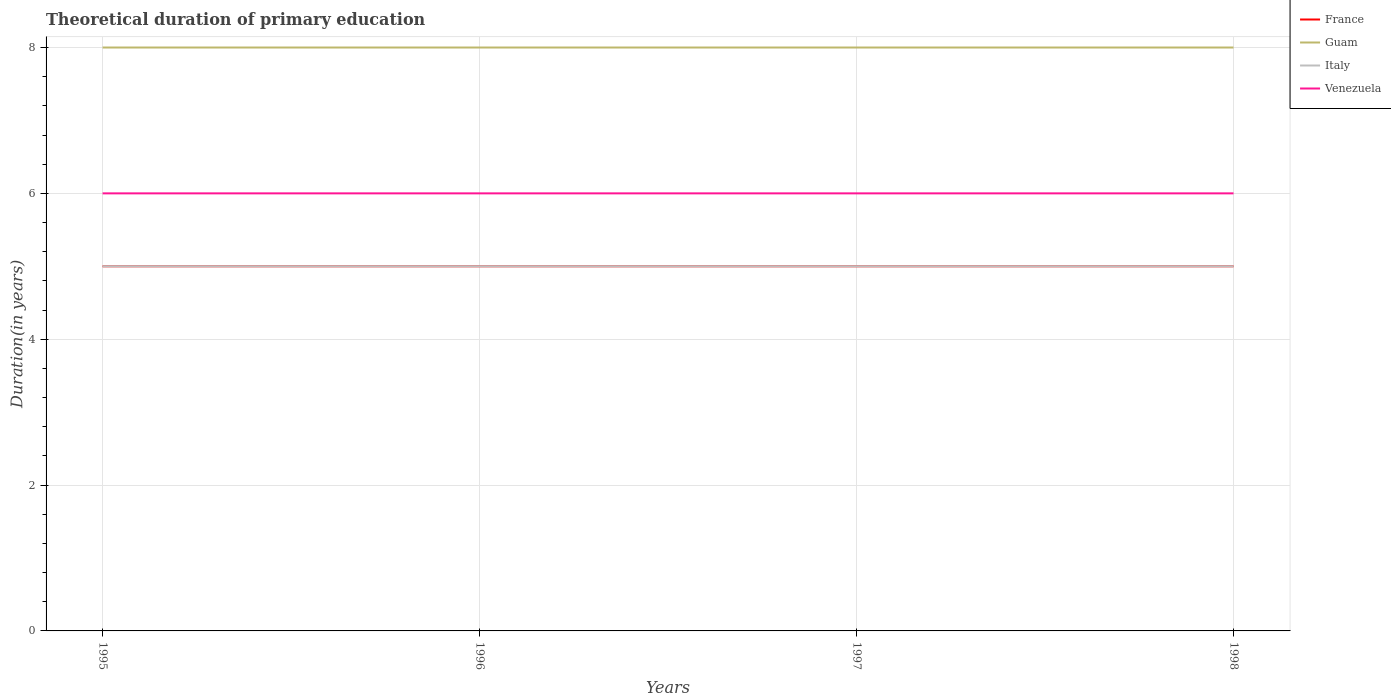How many different coloured lines are there?
Offer a terse response. 4. Does the line corresponding to Italy intersect with the line corresponding to Venezuela?
Provide a short and direct response. No. Across all years, what is the maximum total theoretical duration of primary education in Italy?
Your answer should be very brief. 5. In which year was the total theoretical duration of primary education in Italy maximum?
Your answer should be compact. 1995. Is the total theoretical duration of primary education in Guam strictly greater than the total theoretical duration of primary education in France over the years?
Keep it short and to the point. No. How many lines are there?
Keep it short and to the point. 4. What is the title of the graph?
Your answer should be very brief. Theoretical duration of primary education. Does "Guinea-Bissau" appear as one of the legend labels in the graph?
Provide a short and direct response. No. What is the label or title of the X-axis?
Provide a short and direct response. Years. What is the label or title of the Y-axis?
Your response must be concise. Duration(in years). What is the Duration(in years) in Venezuela in 1995?
Make the answer very short. 6. What is the Duration(in years) of France in 1996?
Your answer should be compact. 5. What is the Duration(in years) in Italy in 1996?
Offer a very short reply. 5. What is the Duration(in years) of Venezuela in 1996?
Offer a terse response. 6. What is the Duration(in years) in France in 1997?
Give a very brief answer. 5. What is the Duration(in years) in Guam in 1997?
Your answer should be compact. 8. What is the Duration(in years) of Guam in 1998?
Offer a terse response. 8. Across all years, what is the maximum Duration(in years) of France?
Make the answer very short. 5. Across all years, what is the maximum Duration(in years) in Italy?
Give a very brief answer. 5. Across all years, what is the maximum Duration(in years) in Venezuela?
Offer a terse response. 6. What is the total Duration(in years) in Italy in the graph?
Your response must be concise. 20. What is the total Duration(in years) in Venezuela in the graph?
Ensure brevity in your answer.  24. What is the difference between the Duration(in years) in France in 1995 and that in 1996?
Your answer should be compact. 0. What is the difference between the Duration(in years) of Guam in 1995 and that in 1997?
Your response must be concise. 0. What is the difference between the Duration(in years) in Venezuela in 1995 and that in 1997?
Your answer should be very brief. 0. What is the difference between the Duration(in years) in France in 1995 and that in 1998?
Provide a short and direct response. 0. What is the difference between the Duration(in years) of Italy in 1995 and that in 1998?
Make the answer very short. 0. What is the difference between the Duration(in years) in Italy in 1996 and that in 1997?
Provide a short and direct response. 0. What is the difference between the Duration(in years) in Venezuela in 1996 and that in 1997?
Ensure brevity in your answer.  0. What is the difference between the Duration(in years) in Guam in 1996 and that in 1998?
Make the answer very short. 0. What is the difference between the Duration(in years) of Venezuela in 1996 and that in 1998?
Ensure brevity in your answer.  0. What is the difference between the Duration(in years) in France in 1997 and that in 1998?
Offer a very short reply. 0. What is the difference between the Duration(in years) in France in 1995 and the Duration(in years) in Guam in 1996?
Your answer should be compact. -3. What is the difference between the Duration(in years) in Guam in 1995 and the Duration(in years) in Italy in 1996?
Your response must be concise. 3. What is the difference between the Duration(in years) of Italy in 1995 and the Duration(in years) of Venezuela in 1996?
Offer a very short reply. -1. What is the difference between the Duration(in years) in France in 1995 and the Duration(in years) in Guam in 1997?
Your answer should be compact. -3. What is the difference between the Duration(in years) in France in 1995 and the Duration(in years) in Italy in 1997?
Offer a terse response. 0. What is the difference between the Duration(in years) in France in 1995 and the Duration(in years) in Venezuela in 1997?
Your answer should be compact. -1. What is the difference between the Duration(in years) of Guam in 1995 and the Duration(in years) of Venezuela in 1997?
Your answer should be compact. 2. What is the difference between the Duration(in years) in Italy in 1995 and the Duration(in years) in Venezuela in 1997?
Provide a short and direct response. -1. What is the difference between the Duration(in years) in France in 1995 and the Duration(in years) in Guam in 1998?
Give a very brief answer. -3. What is the difference between the Duration(in years) of France in 1995 and the Duration(in years) of Italy in 1998?
Provide a succinct answer. 0. What is the difference between the Duration(in years) of France in 1995 and the Duration(in years) of Venezuela in 1998?
Your answer should be compact. -1. What is the difference between the Duration(in years) of Guam in 1995 and the Duration(in years) of Italy in 1998?
Make the answer very short. 3. What is the difference between the Duration(in years) in Guam in 1995 and the Duration(in years) in Venezuela in 1998?
Give a very brief answer. 2. What is the difference between the Duration(in years) in Italy in 1995 and the Duration(in years) in Venezuela in 1998?
Your response must be concise. -1. What is the difference between the Duration(in years) of France in 1996 and the Duration(in years) of Italy in 1997?
Your answer should be compact. 0. What is the difference between the Duration(in years) in Italy in 1996 and the Duration(in years) in Venezuela in 1997?
Provide a succinct answer. -1. What is the difference between the Duration(in years) of France in 1996 and the Duration(in years) of Italy in 1998?
Your answer should be compact. 0. What is the difference between the Duration(in years) in Italy in 1996 and the Duration(in years) in Venezuela in 1998?
Your response must be concise. -1. What is the difference between the Duration(in years) in France in 1997 and the Duration(in years) in Guam in 1998?
Make the answer very short. -3. What is the difference between the Duration(in years) of Guam in 1997 and the Duration(in years) of Italy in 1998?
Offer a very short reply. 3. What is the average Duration(in years) in Guam per year?
Ensure brevity in your answer.  8. What is the average Duration(in years) of Venezuela per year?
Ensure brevity in your answer.  6. In the year 1995, what is the difference between the Duration(in years) of France and Duration(in years) of Guam?
Offer a very short reply. -3. In the year 1995, what is the difference between the Duration(in years) in France and Duration(in years) in Venezuela?
Make the answer very short. -1. In the year 1995, what is the difference between the Duration(in years) of Italy and Duration(in years) of Venezuela?
Provide a succinct answer. -1. In the year 1996, what is the difference between the Duration(in years) in France and Duration(in years) in Italy?
Give a very brief answer. 0. In the year 1996, what is the difference between the Duration(in years) in Guam and Duration(in years) in Venezuela?
Your answer should be very brief. 2. In the year 1997, what is the difference between the Duration(in years) in France and Duration(in years) in Guam?
Keep it short and to the point. -3. In the year 1997, what is the difference between the Duration(in years) in France and Duration(in years) in Venezuela?
Your response must be concise. -1. In the year 1997, what is the difference between the Duration(in years) of Italy and Duration(in years) of Venezuela?
Ensure brevity in your answer.  -1. In the year 1998, what is the difference between the Duration(in years) in France and Duration(in years) in Guam?
Your response must be concise. -3. In the year 1998, what is the difference between the Duration(in years) in France and Duration(in years) in Italy?
Give a very brief answer. 0. In the year 1998, what is the difference between the Duration(in years) in Guam and Duration(in years) in Italy?
Your response must be concise. 3. In the year 1998, what is the difference between the Duration(in years) in Guam and Duration(in years) in Venezuela?
Your response must be concise. 2. In the year 1998, what is the difference between the Duration(in years) of Italy and Duration(in years) of Venezuela?
Your answer should be very brief. -1. What is the ratio of the Duration(in years) in France in 1995 to that in 1996?
Offer a very short reply. 1. What is the ratio of the Duration(in years) of Guam in 1995 to that in 1997?
Offer a terse response. 1. What is the ratio of the Duration(in years) of France in 1995 to that in 1998?
Your answer should be very brief. 1. What is the ratio of the Duration(in years) in Guam in 1995 to that in 1998?
Make the answer very short. 1. What is the ratio of the Duration(in years) in Italy in 1995 to that in 1998?
Offer a very short reply. 1. What is the ratio of the Duration(in years) in Venezuela in 1995 to that in 1998?
Ensure brevity in your answer.  1. What is the ratio of the Duration(in years) in France in 1996 to that in 1997?
Keep it short and to the point. 1. What is the ratio of the Duration(in years) in Guam in 1996 to that in 1997?
Give a very brief answer. 1. What is the ratio of the Duration(in years) in Venezuela in 1996 to that in 1997?
Your response must be concise. 1. What is the ratio of the Duration(in years) in Guam in 1996 to that in 1998?
Offer a very short reply. 1. What is the ratio of the Duration(in years) of Italy in 1996 to that in 1998?
Make the answer very short. 1. What is the ratio of the Duration(in years) of Venezuela in 1996 to that in 1998?
Offer a very short reply. 1. What is the ratio of the Duration(in years) of Italy in 1997 to that in 1998?
Offer a terse response. 1. What is the difference between the highest and the second highest Duration(in years) of Guam?
Ensure brevity in your answer.  0. What is the difference between the highest and the second highest Duration(in years) in Venezuela?
Give a very brief answer. 0. What is the difference between the highest and the lowest Duration(in years) of France?
Ensure brevity in your answer.  0. What is the difference between the highest and the lowest Duration(in years) in Italy?
Ensure brevity in your answer.  0. 